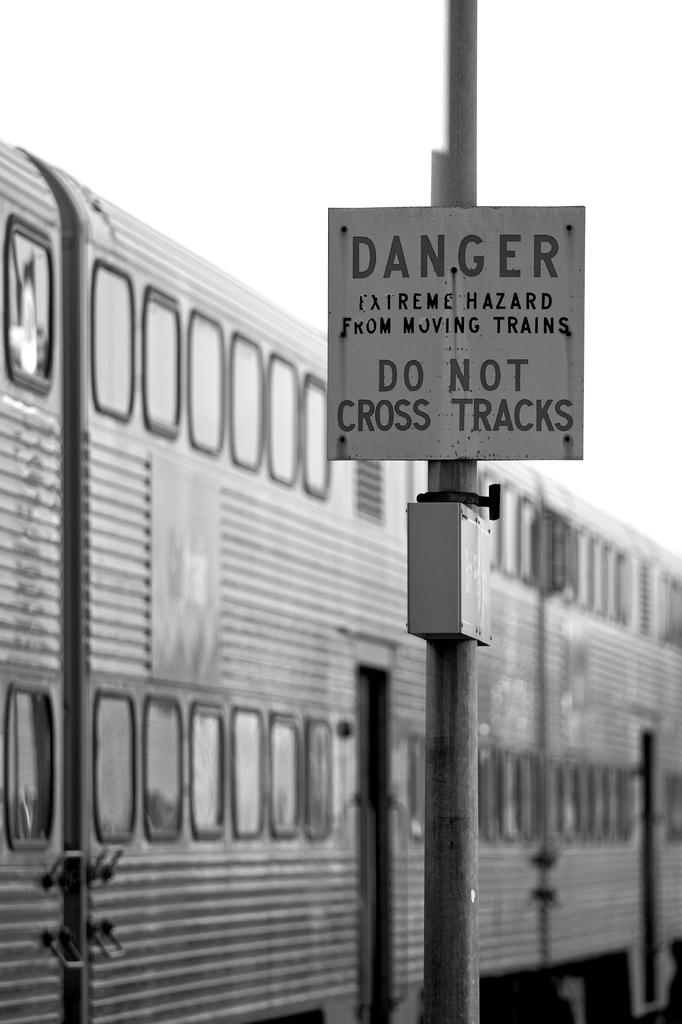What is on the pole in the image? There is a notice board on a pole in the image. What can be seen on the left side of the image? There appears to be a train on the left side of the image. Where is the coal stored in the image? There is no coal present in the image. How many houses are visible in the image? There are no houses visible in the image. What type of medical facility is shown in the image? There is no hospital or medical facility present in the image. 